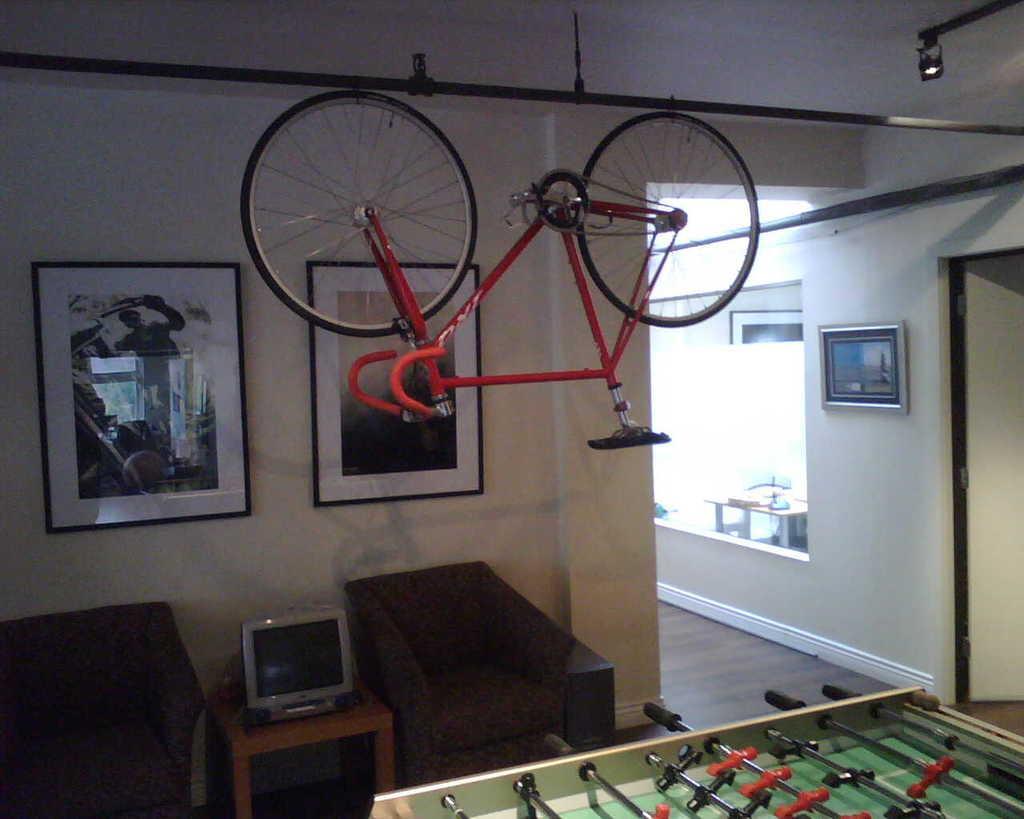Could you give a brief overview of what you see in this image? In this image i can see a bi-cycle hanging to a rope,there is a desktop on a table, there are two couches. At the back ground there is a wall two frames attached to the wall. 